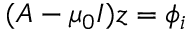<formula> <loc_0><loc_0><loc_500><loc_500>( A - \mu _ { 0 } I ) z = \phi _ { i }</formula> 